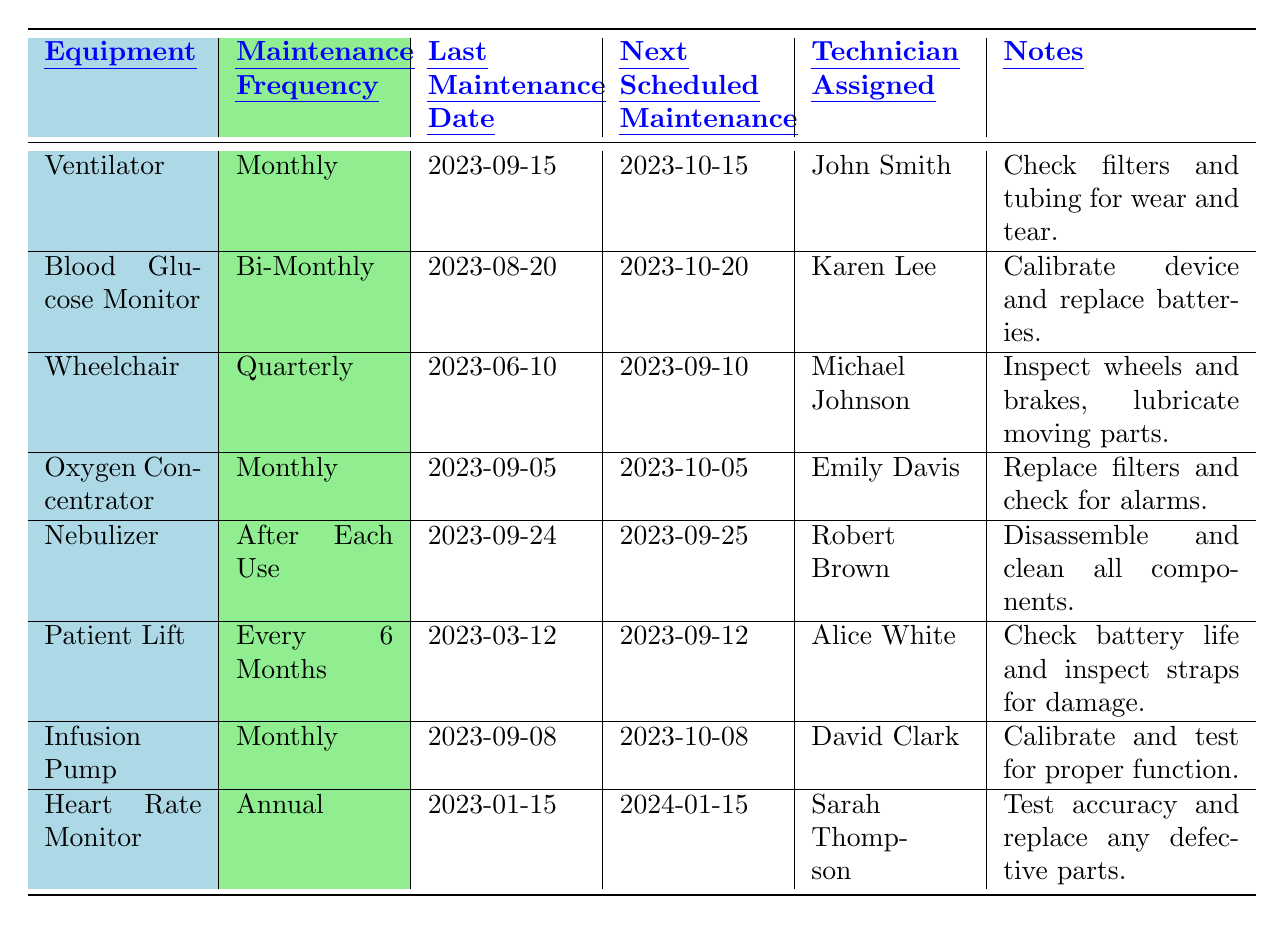What is the maintenance frequency for the Infusion Pump? The table indicates that the maintenance frequency for the Infusion Pump is listed under the "Maintenance Frequency" column. Upon inspection, it shows "Monthly."
Answer: Monthly Who is assigned to maintain the Blood Glucose Monitor? To find the technician assigned to maintain the Blood Glucose Monitor, we can look at the "Technician Assigned" column corresponding to it. The name listed there is "Karen Lee."
Answer: Karen Lee When is the next scheduled maintenance for the Oxygen Concentrator? To get the next scheduled maintenance date for the Oxygen Concentrator, we refer to the "Next Scheduled Maintenance" column for that equipment, which shows "2023-10-05."
Answer: 2023-10-05 How many pieces of equipment require monthly maintenance? We check the "Maintenance Frequency" column for equipment labeled as "Monthly." The corresponding equipment is the Ventilator, Oxygen Concentrator, and Infusion Pump, totaling three.
Answer: 3 Is the last maintenance date for the Patient Lift more recent than the last maintenance date for the Wheelchair? We compare the "Last Maintenance Date" for both the Patient Lift (2023-03-12) and the Wheelchair (2023-06-10). Since March is earlier than June, the Patient Lift's date is not more recent.
Answer: No What type of maintenance frequency does the Nebulizer have? The maintenance frequency for the Nebulizer can be found in the "Maintenance Frequency" column, where it is stated as "After Each Use."
Answer: After Each Use When is the Heart Rate Monitor's next scheduled maintenance? To find the next scheduled maintenance for the Heart Rate Monitor, we check the "Next Scheduled Maintenance" column, which indicates "2024-01-15."
Answer: 2024-01-15 Which technician is responsible for the next scheduled maintenance of the Wheelchair? By looking at the "Technician Assigned" column associated with the Wheelchair entry, we find that "Michael Johnson" is the technician responsible for its next scheduled maintenance.
Answer: Michael Johnson What equipment has the latest next scheduled maintenance date? To determine the equipment with the latest next scheduled maintenance date, we look at all the entries under the "Next Scheduled Maintenance" column. The latest date is for the Heart Rate Monitor (2024-01-15), making it the equipment in question.
Answer: Heart Rate Monitor Is the maintenance for the Oxygen Concentrator scheduled before or after the Wheelchair's next scheduled maintenance? The next scheduled maintenance for the Oxygen Concentrator is on 2023-10-05, while for the Wheelchair, it is on 2023-09-10. Since October is after September, the Oxygen Concentrator's maintenance is scheduled after the Wheelchair's.
Answer: After How often does the equipment maintained by Robert Brown require maintenance? We find the technician Robert Brown associated with the Nebulizer in the table. Referring to the maintenance frequency for the Nebulizer, it states "After Each Use."
Answer: After Each Use 